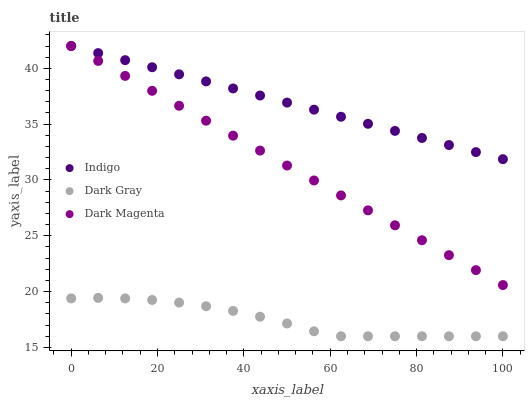Does Dark Gray have the minimum area under the curve?
Answer yes or no. Yes. Does Indigo have the maximum area under the curve?
Answer yes or no. Yes. Does Dark Magenta have the minimum area under the curve?
Answer yes or no. No. Does Dark Magenta have the maximum area under the curve?
Answer yes or no. No. Is Indigo the smoothest?
Answer yes or no. Yes. Is Dark Gray the roughest?
Answer yes or no. Yes. Is Dark Magenta the smoothest?
Answer yes or no. No. Is Dark Magenta the roughest?
Answer yes or no. No. Does Dark Gray have the lowest value?
Answer yes or no. Yes. Does Dark Magenta have the lowest value?
Answer yes or no. No. Does Dark Magenta have the highest value?
Answer yes or no. Yes. Is Dark Gray less than Dark Magenta?
Answer yes or no. Yes. Is Dark Magenta greater than Dark Gray?
Answer yes or no. Yes. Does Indigo intersect Dark Magenta?
Answer yes or no. Yes. Is Indigo less than Dark Magenta?
Answer yes or no. No. Is Indigo greater than Dark Magenta?
Answer yes or no. No. Does Dark Gray intersect Dark Magenta?
Answer yes or no. No. 